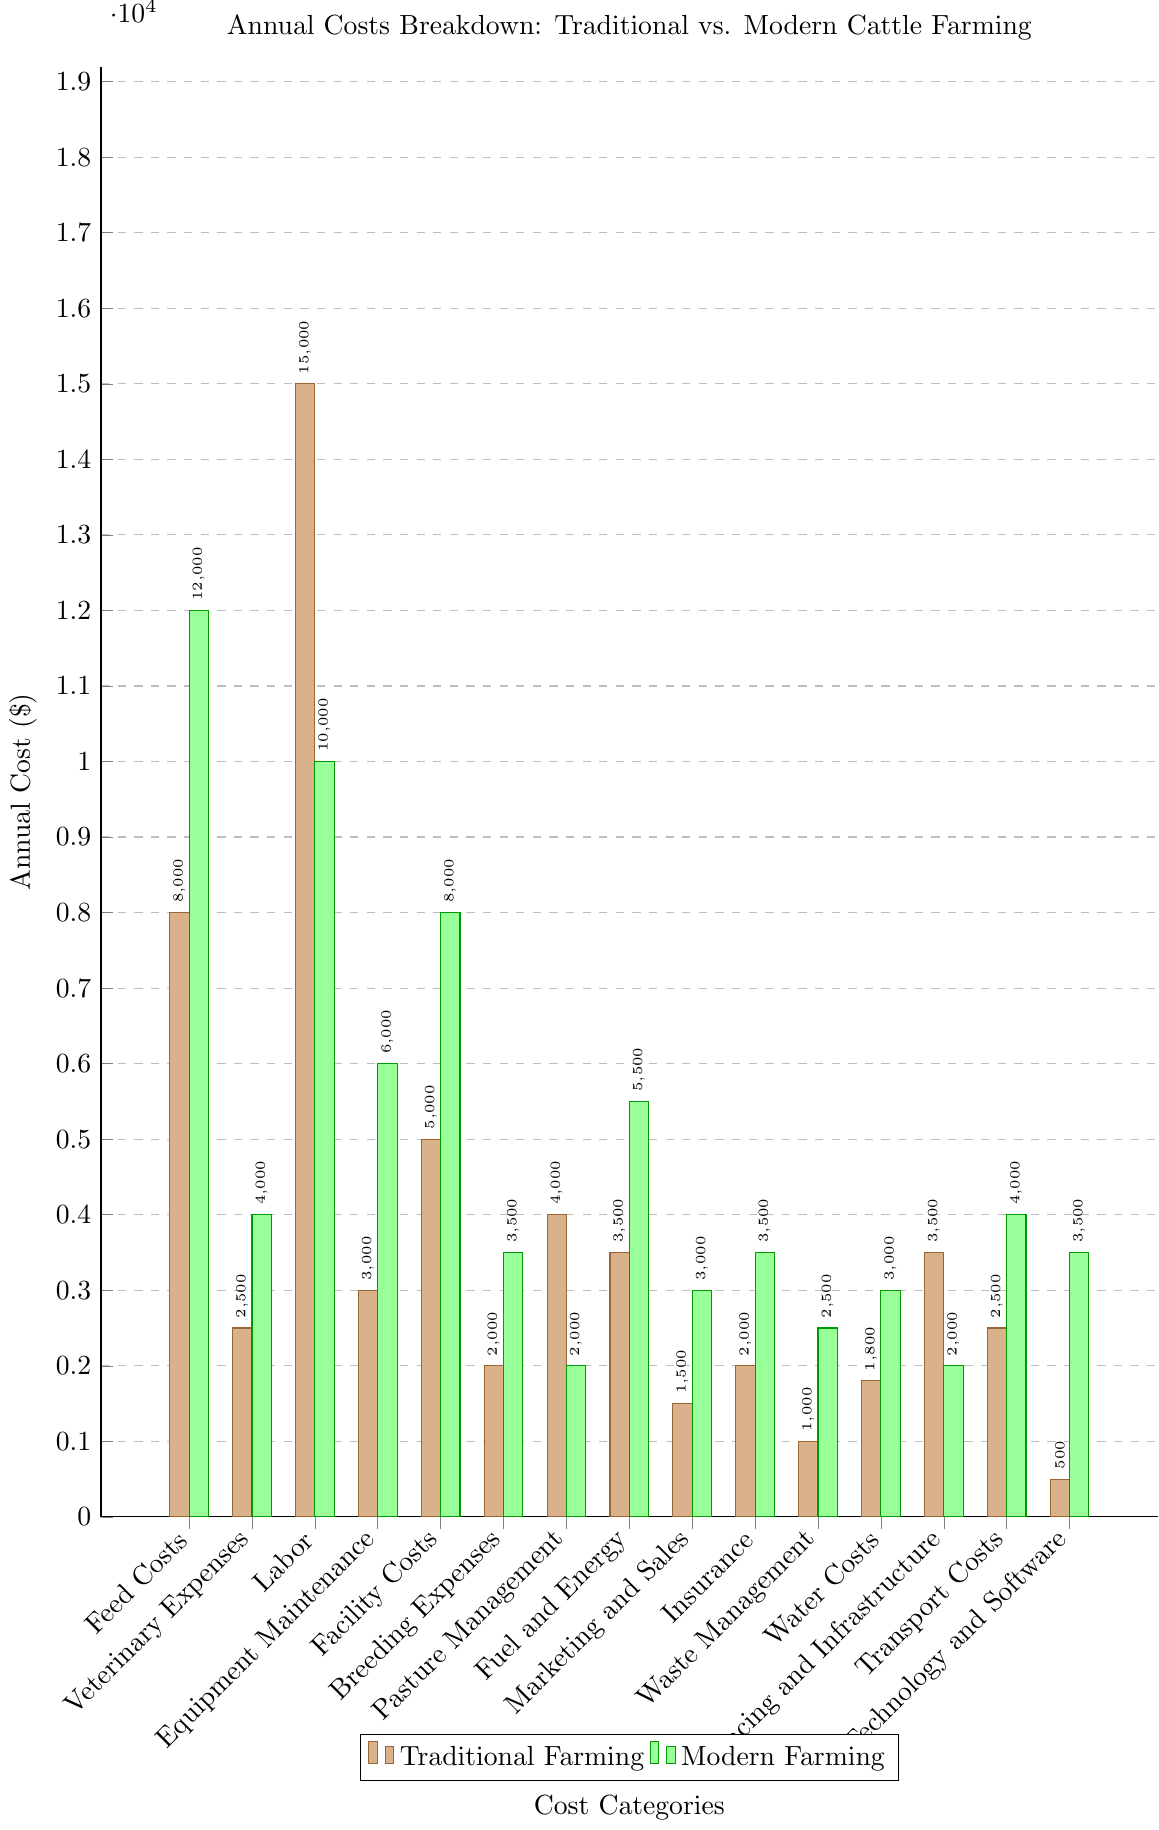Which farming technique has higher feed costs? The bar representing feed costs for modern farming is visually higher than the one for traditional farming.
Answer: Modern Farming What's the sum of facility costs and fuel and energy costs in traditional farming? From the chart, the facility costs for traditional farming is 5000 and the fuel and energy costs is 3500. The sum is 5000 + 3500.
Answer: 8500 How much more is spent on veterinary expenses in modern farming compared to traditional farming? The bar chart shows veterinary expenses as 4000 for modern farming and 2500 for traditional farming. The difference is 4000 - 2500.
Answer: 1500 Which cost category shows the least difference between traditional and modern farming? By comparing the heights of the bars, the category with the smallest difference is Breeding Expenses (2000 for traditional and 3500 for modern).
Answer: Breeding Expenses Are labor costs higher in traditional or modern farming? The bar for labor costs in traditional farming is higher at 15000 compared to 10000 for modern farming.
Answer: Traditional Farming What is the combined cost of technology and software in both farming techniques? Technology and software costs are 500 for traditional and 3500 for modern farming. The combined cost is 500 + 3500.
Answer: 4000 Which farming method spends more on water costs, and by how much? The bar chart shows water costs as 1800 for traditional farming and 3000 for modern farming. The difference is 3000 - 1800.
Answer: Modern Farming by 1200 Is marketing and sales expense higher in modern farming or traditional farming, and by how much? Marketing and sales expenses are 1500 for traditional and 3000 for modern farming. The difference is 3000 - 1500.
Answer: Modern Farming by 1500 Which farming technique incurs greater waste management costs? The chart shows a higher bar for waste management costs in modern farming (2500) compared to traditional farming (1000).
Answer: Modern Farming 